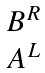Convert formula to latex. <formula><loc_0><loc_0><loc_500><loc_500>\begin{matrix} B ^ { R } \\ A ^ { L } \end{matrix}</formula> 